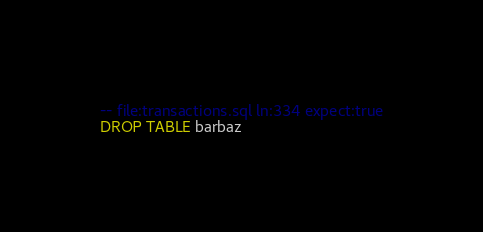<code> <loc_0><loc_0><loc_500><loc_500><_SQL_>-- file:transactions.sql ln:334 expect:true
DROP TABLE barbaz
</code> 